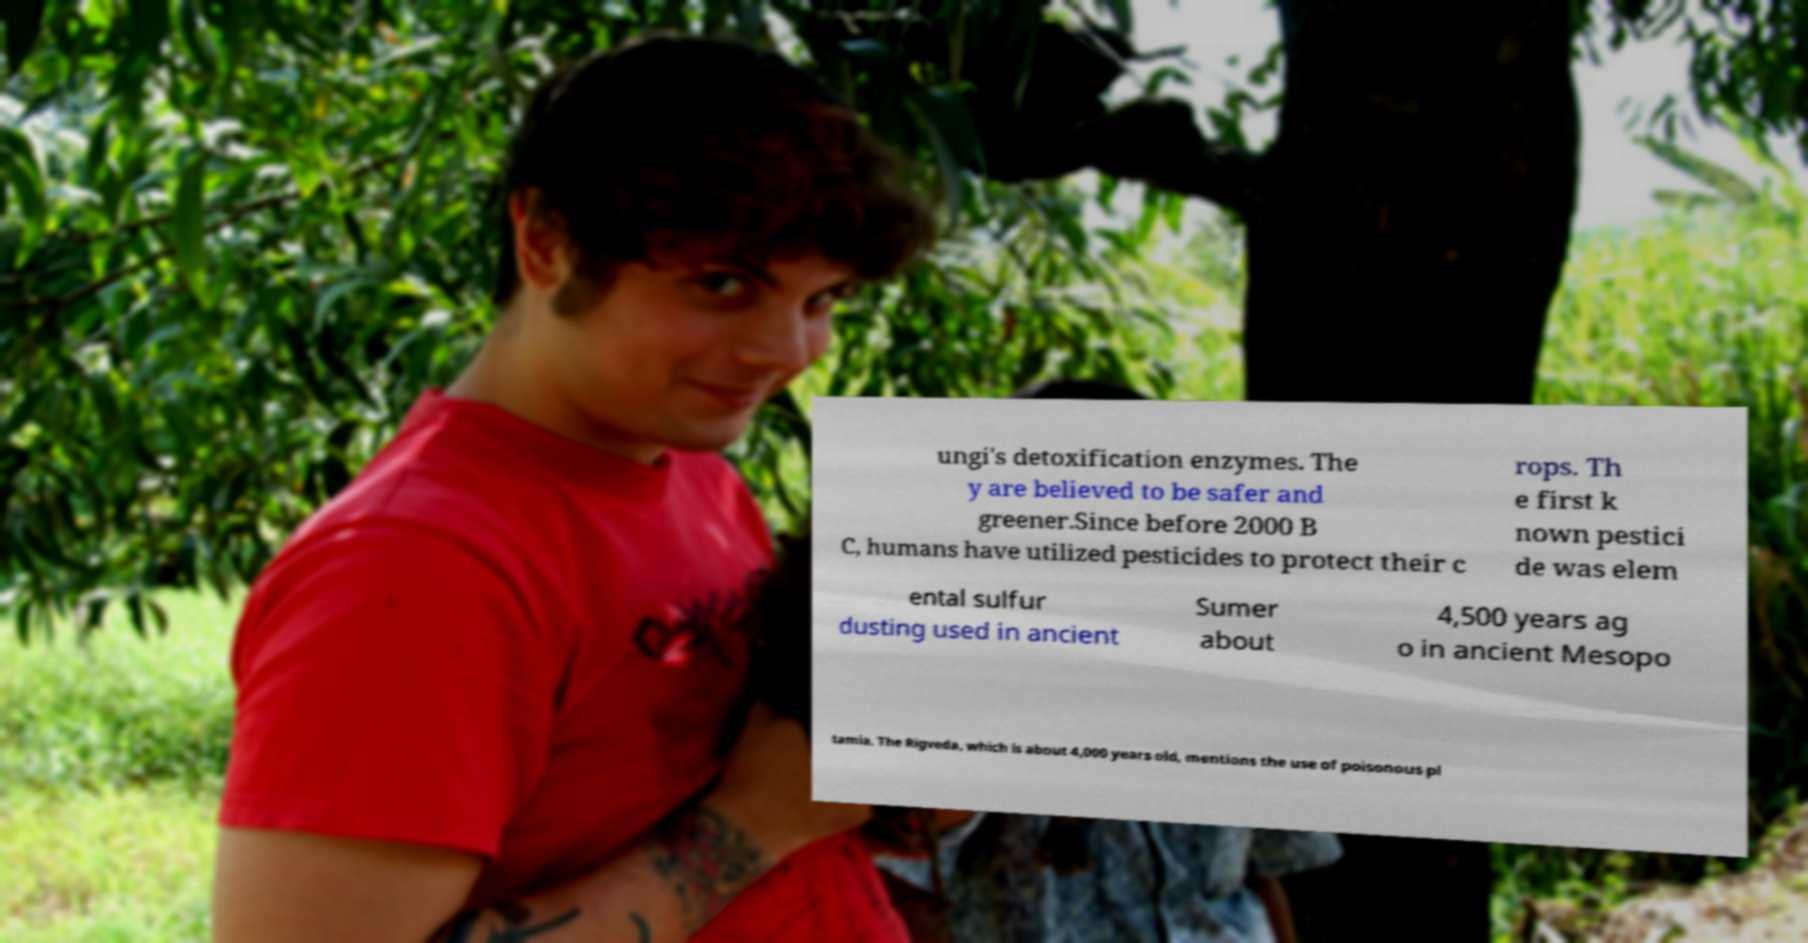Could you assist in decoding the text presented in this image and type it out clearly? ungi's detoxification enzymes. The y are believed to be safer and greener.Since before 2000 B C, humans have utilized pesticides to protect their c rops. Th e first k nown pestici de was elem ental sulfur dusting used in ancient Sumer about 4,500 years ag o in ancient Mesopo tamia. The Rigveda, which is about 4,000 years old, mentions the use of poisonous pl 